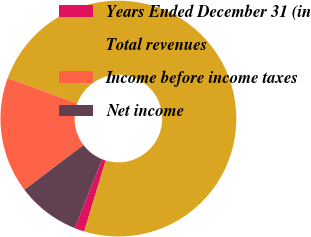Convert chart. <chart><loc_0><loc_0><loc_500><loc_500><pie_chart><fcel>Years Ended December 31 (in<fcel>Total revenues<fcel>Income before income taxes<fcel>Net income<nl><fcel>1.36%<fcel>74.09%<fcel>15.91%<fcel>8.64%<nl></chart> 